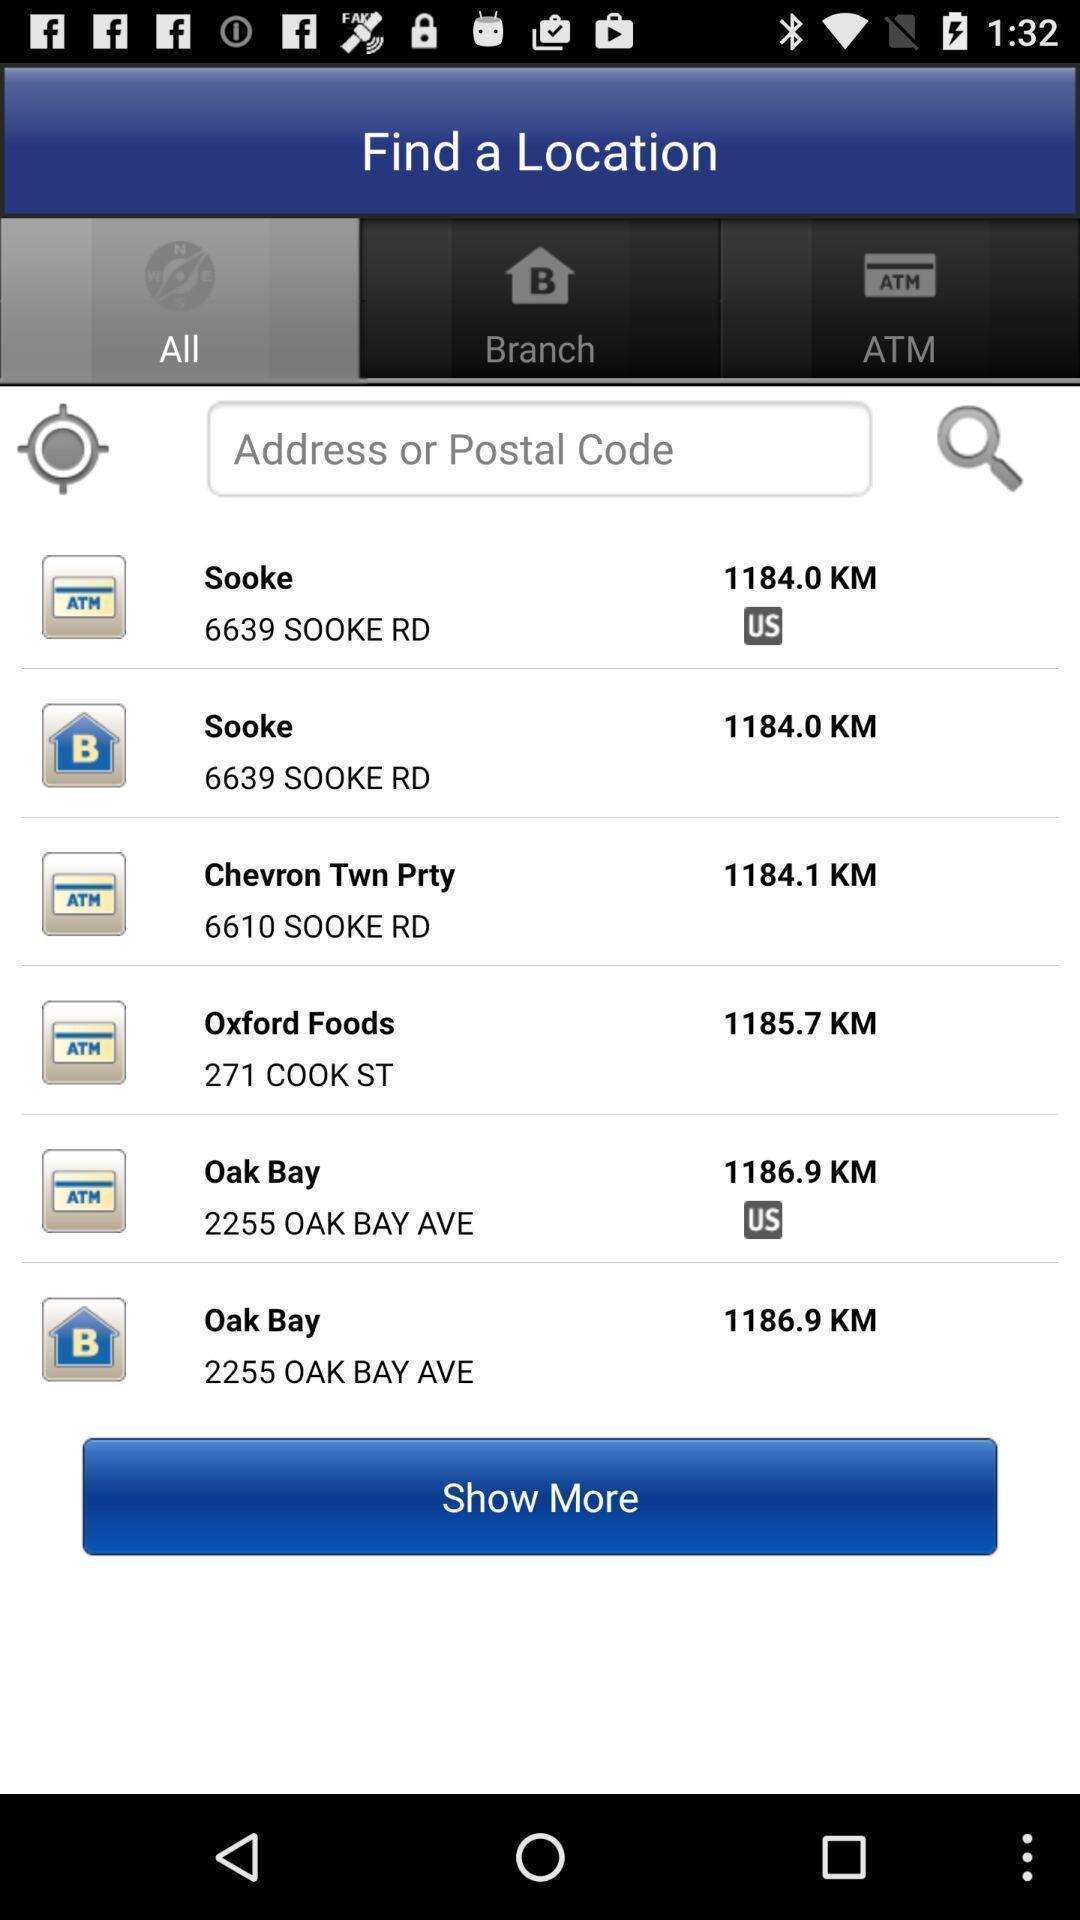What details can you identify in this image? Search option to find the location using code. 